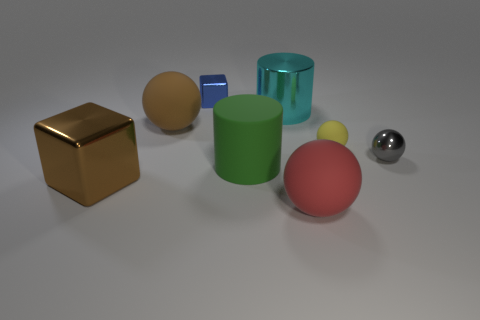What is the size of the matte sphere that is both on the right side of the big rubber cylinder and left of the small yellow ball?
Give a very brief answer. Large. What color is the other large object that is the same shape as the brown matte object?
Keep it short and to the point. Red. Is the number of green cylinders that are behind the small rubber ball greater than the number of big red spheres that are behind the blue shiny cube?
Give a very brief answer. No. What number of other things are there of the same shape as the tiny matte thing?
Give a very brief answer. 3. There is a metal thing right of the red rubber thing; are there any tiny metal objects that are to the right of it?
Your answer should be very brief. No. How many small gray matte things are there?
Give a very brief answer. 0. There is a tiny rubber object; does it have the same color as the metallic object in front of the gray shiny ball?
Your answer should be very brief. No. Are there more shiny blocks than big brown metallic cubes?
Make the answer very short. Yes. Are there any other things of the same color as the large block?
Your answer should be very brief. Yes. What number of other things are the same size as the brown matte thing?
Provide a succinct answer. 4. 